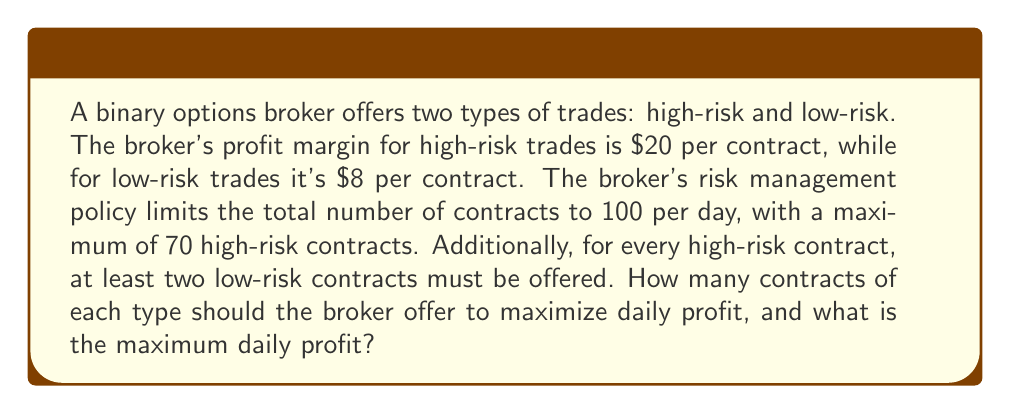Can you solve this math problem? Let's approach this problem using linear programming:

1. Define variables:
   Let $x$ = number of high-risk contracts
   Let $y$ = number of low-risk contracts

2. Objective function:
   Maximize profit: $Z = 20x + 8y$

3. Constraints:
   a) Total contracts: $x + y \leq 100$
   b) High-risk limit: $x \leq 70$
   c) Risk balance: $x \leq \frac{1}{2}y$
   d) Non-negativity: $x \geq 0, y \geq 0$

4. Solve graphically or using the simplex method:

   The feasible region is determined by the constraints. The optimal solution will be at one of the corner points of this region.

   Corner points:
   (0, 0), (0, 100), (70, 30), (33.33, 66.67)

   Evaluate Z at each point:
   Z(0, 0) = 0
   Z(0, 100) = 800
   Z(70, 30) = 1640
   Z(33.33, 66.67) ≈ 1200

5. The maximum Z value occurs at (70, 30), which satisfies all constraints.

Therefore, the broker should offer 70 high-risk contracts and 30 low-risk contracts to maximize profit.

The maximum daily profit is:
$Z = 20(70) + 8(30) = 1400 + 240 = 1640$
Answer: The broker should offer 70 high-risk contracts and 30 low-risk contracts. The maximum daily profit is $1640. 